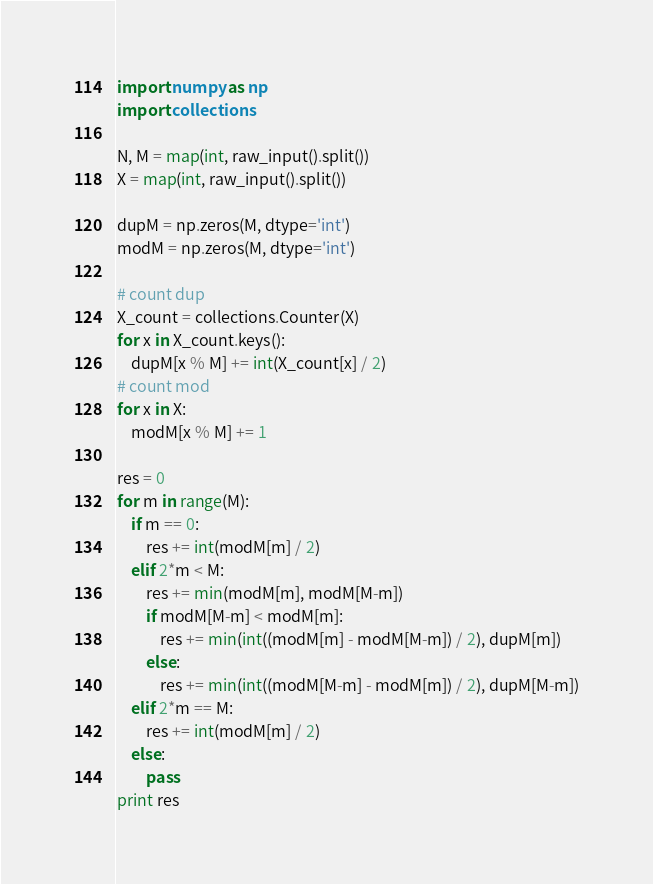Convert code to text. <code><loc_0><loc_0><loc_500><loc_500><_Python_>import numpy as np
import collections

N, M = map(int, raw_input().split())
X = map(int, raw_input().split())

dupM = np.zeros(M, dtype='int')
modM = np.zeros(M, dtype='int')

# count dup
X_count = collections.Counter(X)
for x in X_count.keys():
    dupM[x % M] += int(X_count[x] / 2)
# count mod
for x in X:
    modM[x % M] += 1

res = 0
for m in range(M):
    if m == 0:
        res += int(modM[m] / 2)
    elif 2*m < M:
        res += min(modM[m], modM[M-m])
        if modM[M-m] < modM[m]:
            res += min(int((modM[m] - modM[M-m]) / 2), dupM[m])
        else:
            res += min(int((modM[M-m] - modM[m]) / 2), dupM[M-m])
    elif 2*m == M:
        res += int(modM[m] / 2)
    else:
        pass
print res</code> 